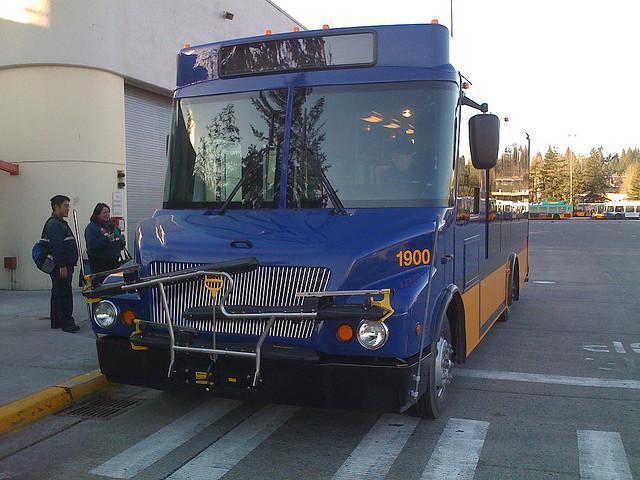How many people are there?
Give a very brief answer. 2. 